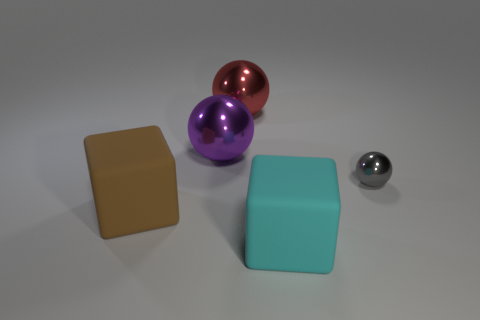Subtract all purple metallic spheres. How many spheres are left? 2 Add 1 purple cylinders. How many objects exist? 6 Subtract all blocks. How many objects are left? 3 Subtract all blue metal balls. Subtract all large cyan matte blocks. How many objects are left? 4 Add 5 brown rubber objects. How many brown rubber objects are left? 6 Add 3 large blocks. How many large blocks exist? 5 Subtract 0 brown spheres. How many objects are left? 5 